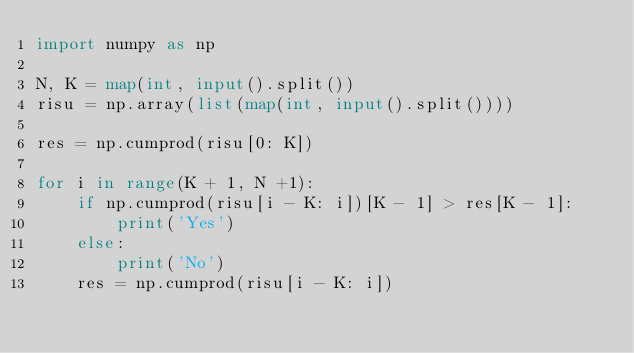<code> <loc_0><loc_0><loc_500><loc_500><_Python_>import numpy as np

N, K = map(int, input().split())
risu = np.array(list(map(int, input().split())))

res = np.cumprod(risu[0: K])

for i in range(K + 1, N +1):
    if np.cumprod(risu[i - K: i])[K - 1] > res[K - 1]:
        print('Yes')
    else:
        print('No')
    res = np.cumprod(risu[i - K: i])</code> 